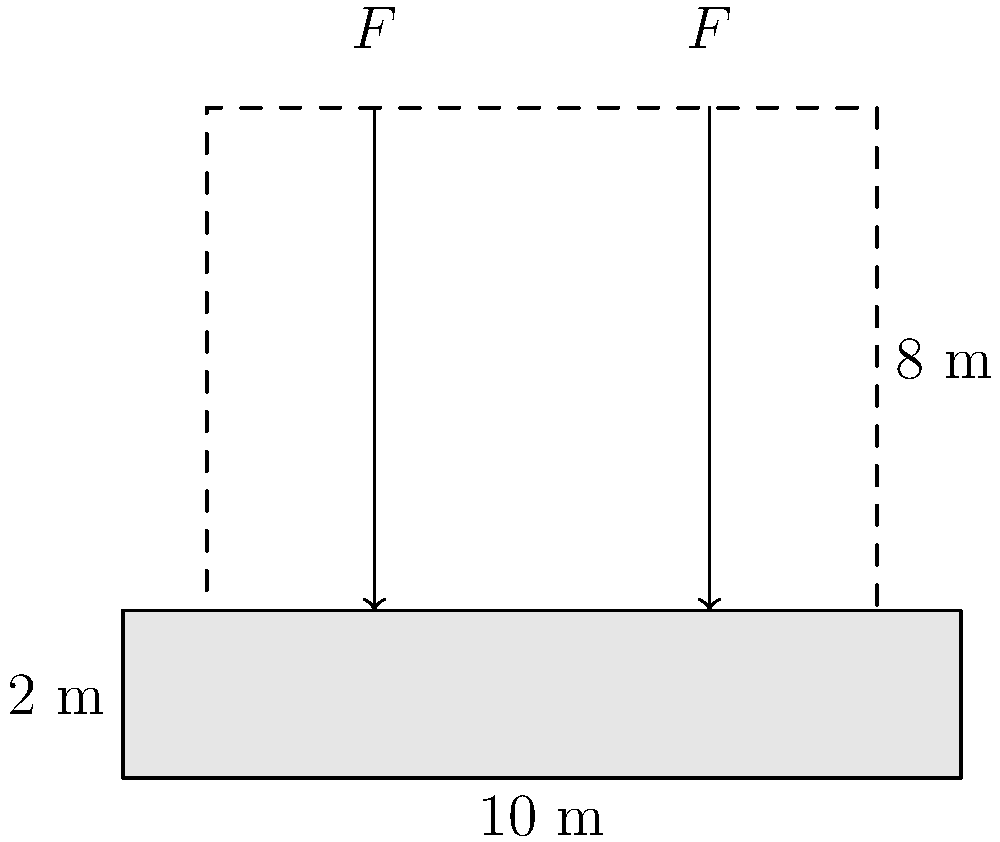As you consider adopting a child, you want to ensure your home is structurally sound. The foundation of your house measures 10 m long, 2 m deep, and spans the entire width of the house. If the allowable soil bearing capacity is 200 kPa and two equal concentrated loads of $F$ = 500 kN are applied as shown, what is the maximum width of the house foundation to ensure the soil bearing capacity is not exceeded? To solve this problem, we'll follow these steps:

1) First, calculate the total load on the foundation:
   Total load = Weight of two concentrated loads
   $P_{total} = 2F = 2 \times 500 \text{ kN} = 1000 \text{ kN}$

2) The allowable soil bearing capacity is given as 200 kPa. This means the pressure on the soil should not exceed this value.

3) The area of the foundation needed to support this load without exceeding the soil bearing capacity is:
   $A_{required} = \frac{P_{total}}{\text{Allowable soil bearing capacity}}$
   $A_{required} = \frac{1000 \text{ kN}}{200 \text{ kPa}} = 5 \text{ m}^2$

4) We know the length of the foundation is 10 m. To find the width:
   $\text{Width} = \frac{A_{required}}{\text{Length}} = \frac{5 \text{ m}^2}{10 \text{ m}} = 0.5 \text{ m}$

5) Therefore, the maximum width of the house foundation to ensure the soil bearing capacity is not exceeded is 0.5 m.

This width is quite narrow for a typical house foundation, which suggests that in a real-world scenario, the foundation might need to be reinforced or redesigned to distribute the load more evenly.
Answer: 0.5 m 